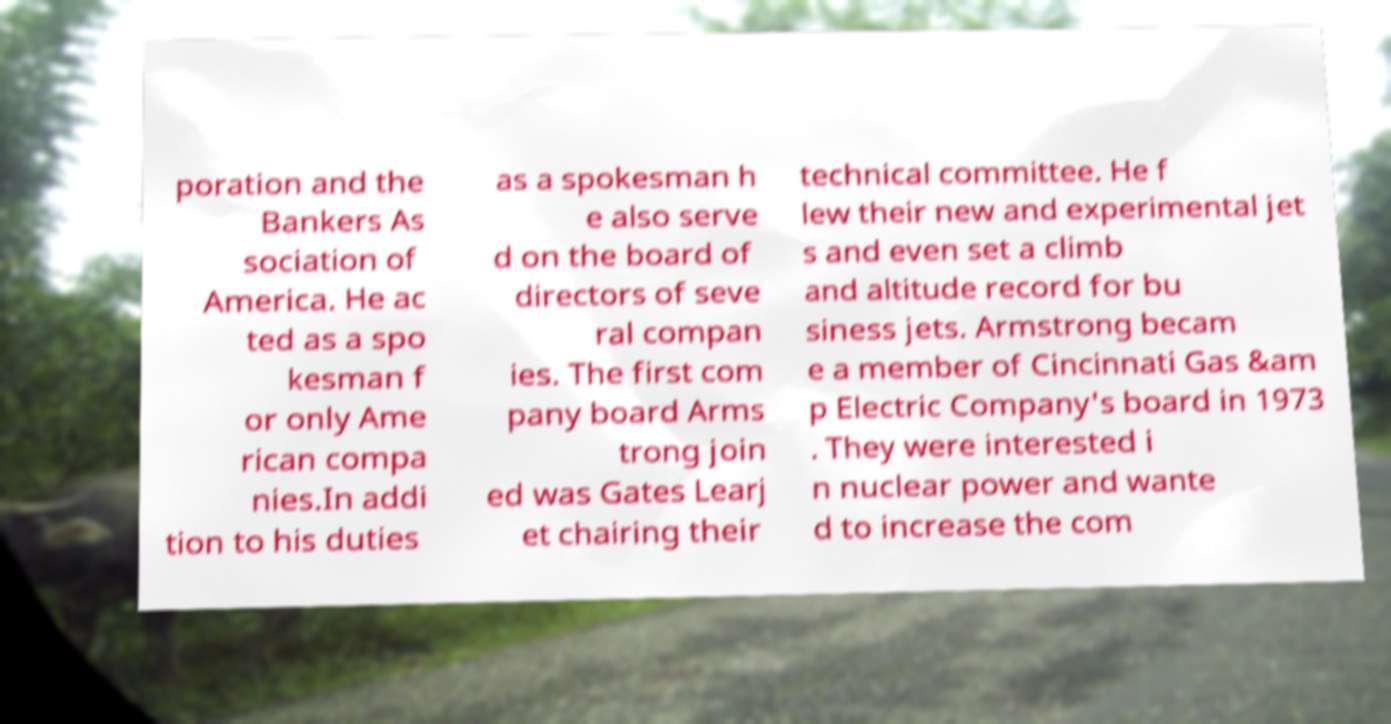Could you assist in decoding the text presented in this image and type it out clearly? poration and the Bankers As sociation of America. He ac ted as a spo kesman f or only Ame rican compa nies.In addi tion to his duties as a spokesman h e also serve d on the board of directors of seve ral compan ies. The first com pany board Arms trong join ed was Gates Learj et chairing their technical committee. He f lew their new and experimental jet s and even set a climb and altitude record for bu siness jets. Armstrong becam e a member of Cincinnati Gas &am p Electric Company's board in 1973 . They were interested i n nuclear power and wante d to increase the com 